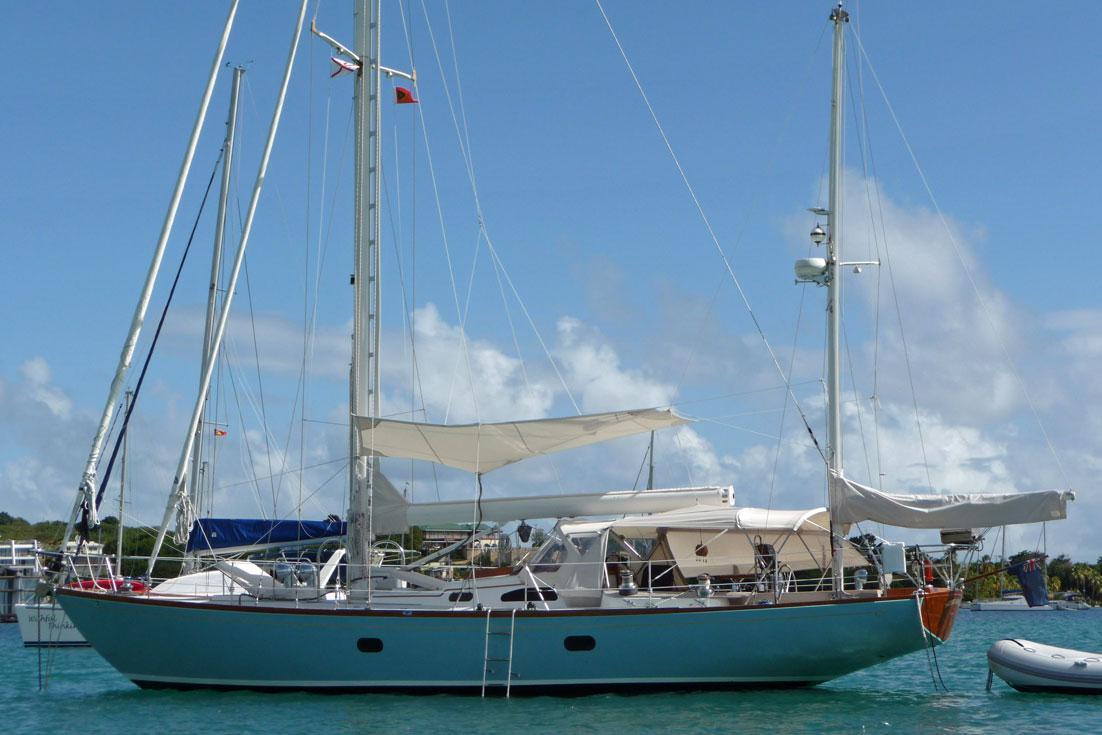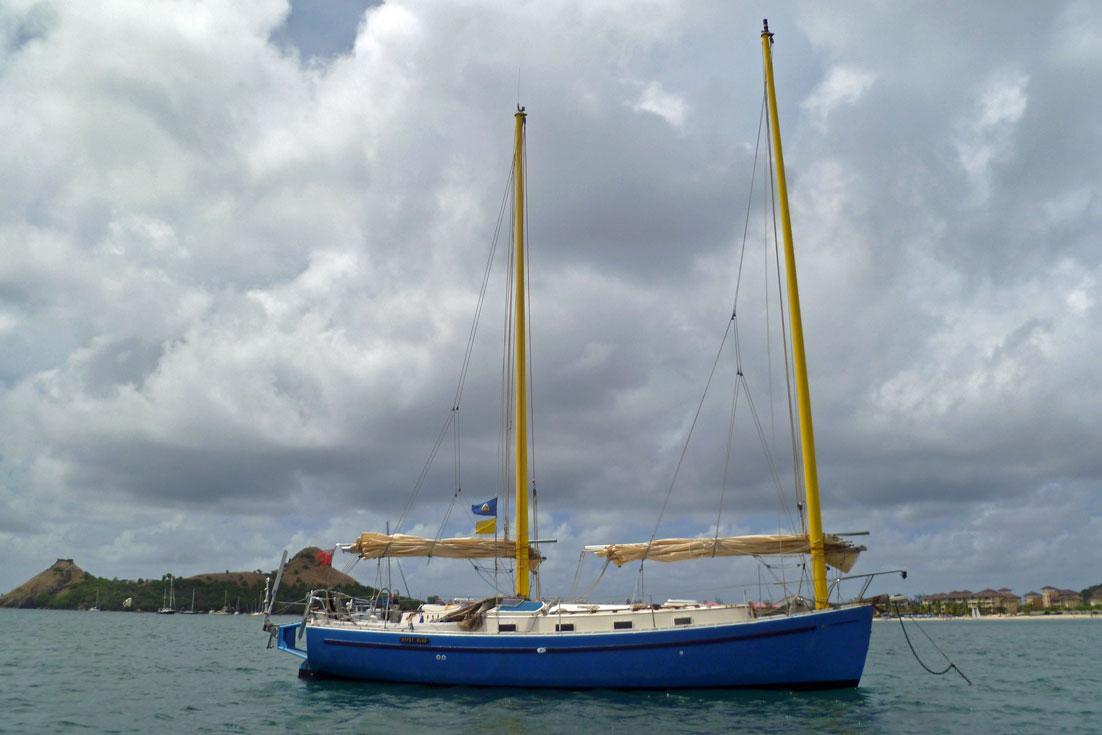The first image is the image on the left, the second image is the image on the right. For the images shown, is this caption "All the boats have their sails up." true? Answer yes or no. No. The first image is the image on the left, the second image is the image on the right. Assess this claim about the two images: "The sails are down on at least one of the vessels.". Correct or not? Answer yes or no. Yes. 